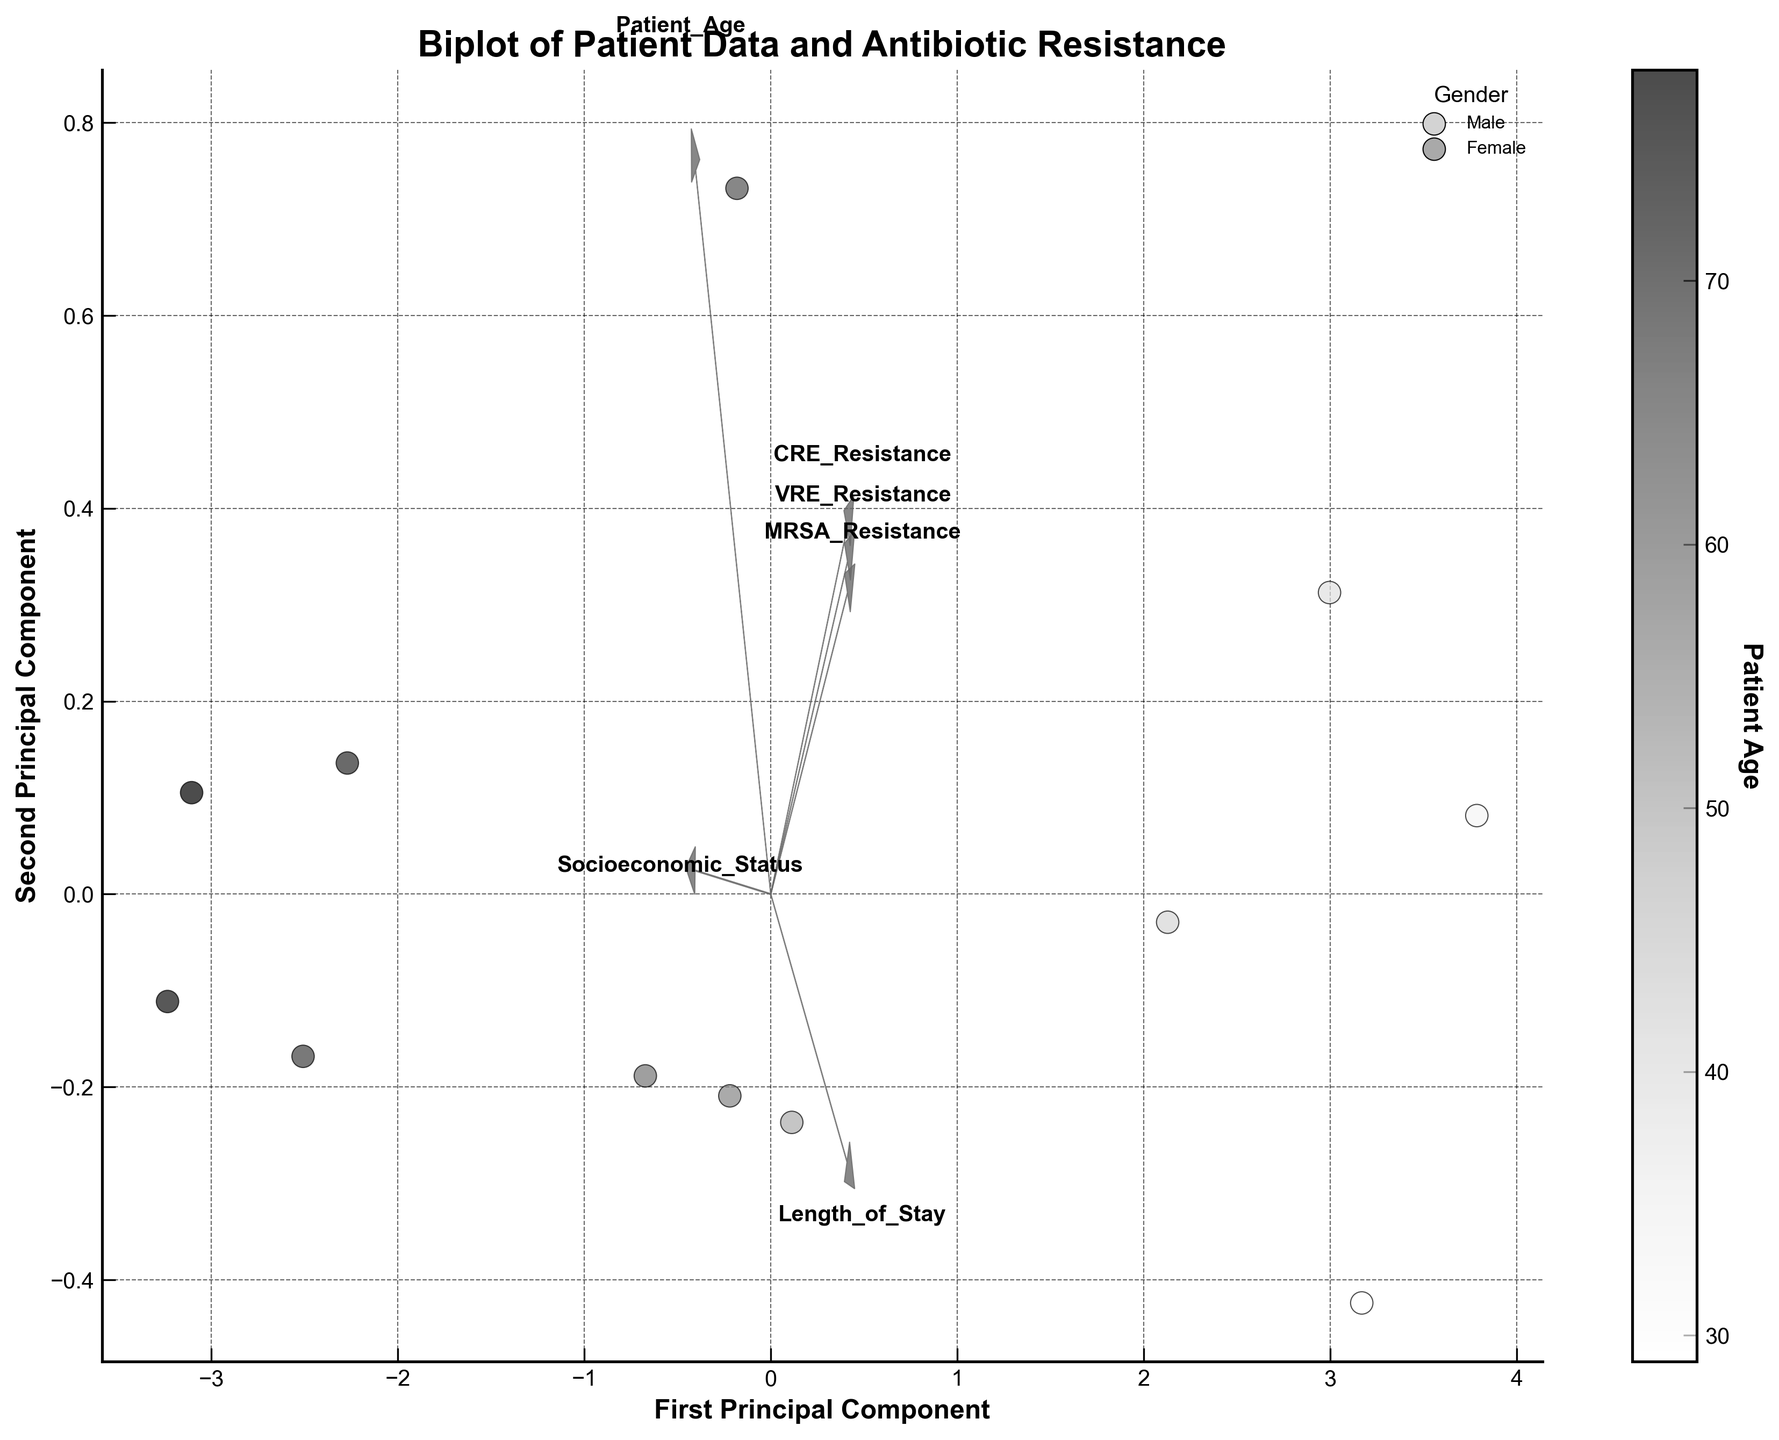What is the title of the biplot? The title of the biplot is displayed at the top of the figure.
Answer: Biplot of Patient Data and Antibiotic Resistance What do the axes represent in this biplot? The x-axis represents the "First Principal Component," and the y-axis represents the "Second Principal Component." These components are derived from Principal Component Analysis (PCA).
Answer: First Principal Component and Second Principal Component Which color represents female patients in the biplot? The color scheme includes light grey for male and dark grey for female. The legend provides this information.
Answer: Dark grey What is the relationship between socioeconomic status and MRSA resistance rates? The arrow for socioeconomic status points in one direction, while MRSA resistance rates have a different arrow direction. If they point in similar directions, they are correlated. Checking the angles helps identify this relationship.
Answer: They are negatively correlated How does length of stay correlate with MRSA resistance? We can determine the correlation by comparing the directions of the arrows for "Length of Stay" and "MRSA Resistance." If they point in similar directions, they highly correlate.
Answer: Positively correlated How many principal components are used in this biplot analysis? The biplot projects data onto two axes representing the First and Second Principal Components.
Answer: Two Are older patients more likely to have higher rates of antibiotic resistance? The color bar indicates patient age. Data points with darker colors (representing older patients) and respective antibiotic resistance directions can help infer the relationship.
Answer: Generally, yes Which features seem to have the strongest influence on the first principal component? The length of the arrows indicates the magnitude of influence. Longer arrows along the first principal component indicate stronger influence.
Answer: Patient_Age, MRSA_Resistance, and VRE_Resistance Does gender influence how points are scattered in this plot? While gender is indicated by color, there isn't a strong clustering pattern solely on gender.
Answer: No significant influence What is the relationship between patient age and length of stay? By observing how the color gradient (indicating age) corresponds to the arrow for "Length of Stay," we can infer the relationship.
Answer: Positively correlated 